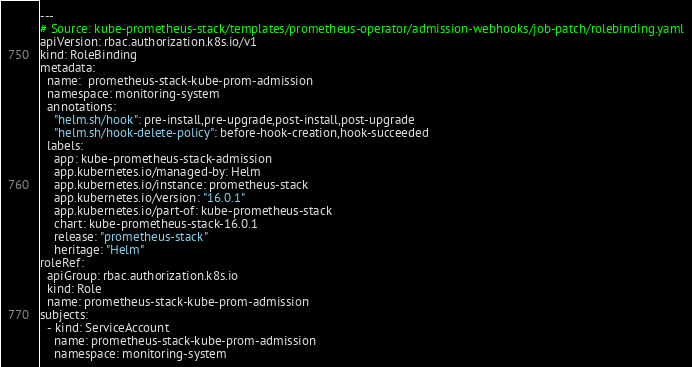Convert code to text. <code><loc_0><loc_0><loc_500><loc_500><_YAML_>---
# Source: kube-prometheus-stack/templates/prometheus-operator/admission-webhooks/job-patch/rolebinding.yaml
apiVersion: rbac.authorization.k8s.io/v1
kind: RoleBinding
metadata:
  name:  prometheus-stack-kube-prom-admission
  namespace: monitoring-system
  annotations:
    "helm.sh/hook": pre-install,pre-upgrade,post-install,post-upgrade
    "helm.sh/hook-delete-policy": before-hook-creation,hook-succeeded
  labels:
    app: kube-prometheus-stack-admission    
    app.kubernetes.io/managed-by: Helm
    app.kubernetes.io/instance: prometheus-stack
    app.kubernetes.io/version: "16.0.1"
    app.kubernetes.io/part-of: kube-prometheus-stack
    chart: kube-prometheus-stack-16.0.1
    release: "prometheus-stack"
    heritage: "Helm"
roleRef:
  apiGroup: rbac.authorization.k8s.io
  kind: Role
  name: prometheus-stack-kube-prom-admission
subjects:
  - kind: ServiceAccount
    name: prometheus-stack-kube-prom-admission
    namespace: monitoring-system
</code> 